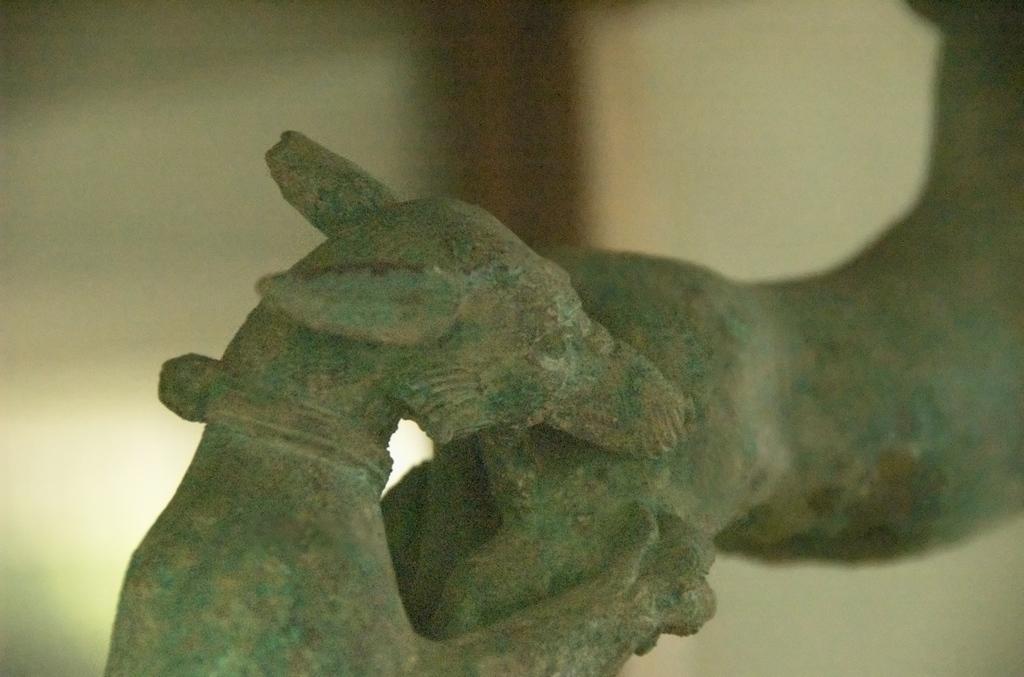How would you summarize this image in a sentence or two? In this image we can see the sculpture. 